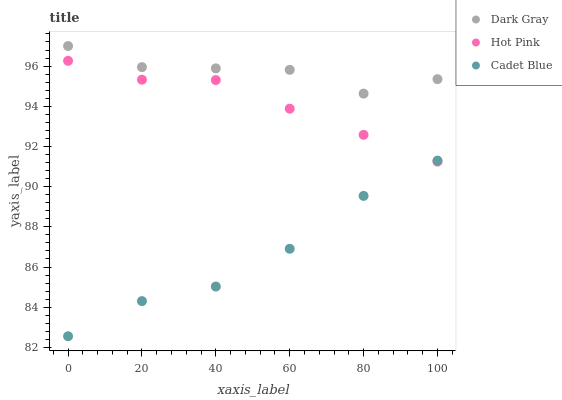Does Cadet Blue have the minimum area under the curve?
Answer yes or no. Yes. Does Dark Gray have the maximum area under the curve?
Answer yes or no. Yes. Does Hot Pink have the minimum area under the curve?
Answer yes or no. No. Does Hot Pink have the maximum area under the curve?
Answer yes or no. No. Is Hot Pink the smoothest?
Answer yes or no. Yes. Is Dark Gray the roughest?
Answer yes or no. Yes. Is Cadet Blue the smoothest?
Answer yes or no. No. Is Cadet Blue the roughest?
Answer yes or no. No. Does Cadet Blue have the lowest value?
Answer yes or no. Yes. Does Hot Pink have the lowest value?
Answer yes or no. No. Does Dark Gray have the highest value?
Answer yes or no. Yes. Does Hot Pink have the highest value?
Answer yes or no. No. Is Hot Pink less than Dark Gray?
Answer yes or no. Yes. Is Dark Gray greater than Cadet Blue?
Answer yes or no. Yes. Does Hot Pink intersect Cadet Blue?
Answer yes or no. Yes. Is Hot Pink less than Cadet Blue?
Answer yes or no. No. Is Hot Pink greater than Cadet Blue?
Answer yes or no. No. Does Hot Pink intersect Dark Gray?
Answer yes or no. No. 